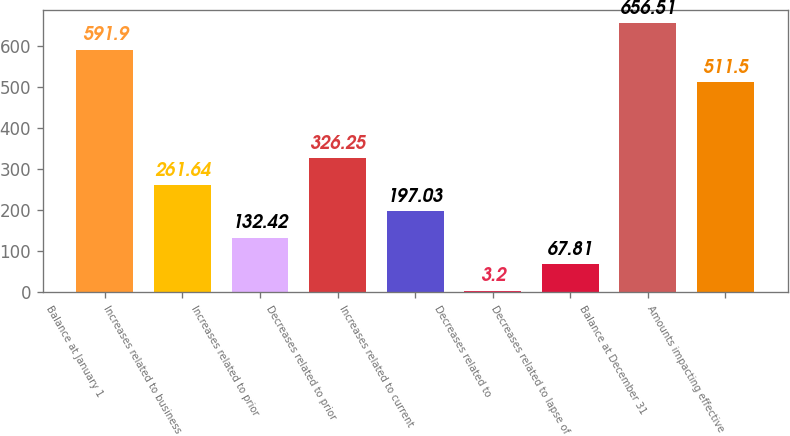Convert chart to OTSL. <chart><loc_0><loc_0><loc_500><loc_500><bar_chart><fcel>Balance at January 1<fcel>Increases related to business<fcel>Increases related to prior<fcel>Decreases related to prior<fcel>Increases related to current<fcel>Decreases related to<fcel>Decreases related to lapse of<fcel>Balance at December 31<fcel>Amounts impacting effective<nl><fcel>591.9<fcel>261.64<fcel>132.42<fcel>326.25<fcel>197.03<fcel>3.2<fcel>67.81<fcel>656.51<fcel>511.5<nl></chart> 